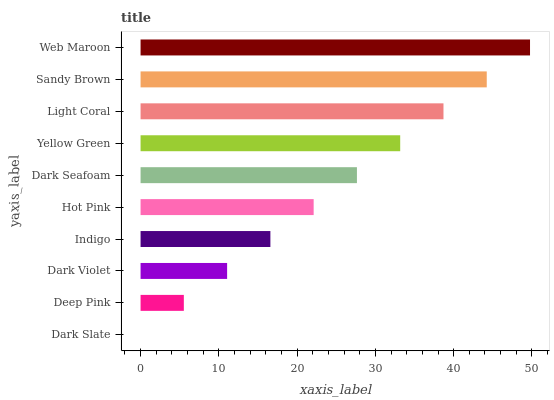Is Dark Slate the minimum?
Answer yes or no. Yes. Is Web Maroon the maximum?
Answer yes or no. Yes. Is Deep Pink the minimum?
Answer yes or no. No. Is Deep Pink the maximum?
Answer yes or no. No. Is Deep Pink greater than Dark Slate?
Answer yes or no. Yes. Is Dark Slate less than Deep Pink?
Answer yes or no. Yes. Is Dark Slate greater than Deep Pink?
Answer yes or no. No. Is Deep Pink less than Dark Slate?
Answer yes or no. No. Is Dark Seafoam the high median?
Answer yes or no. Yes. Is Hot Pink the low median?
Answer yes or no. Yes. Is Hot Pink the high median?
Answer yes or no. No. Is Dark Slate the low median?
Answer yes or no. No. 